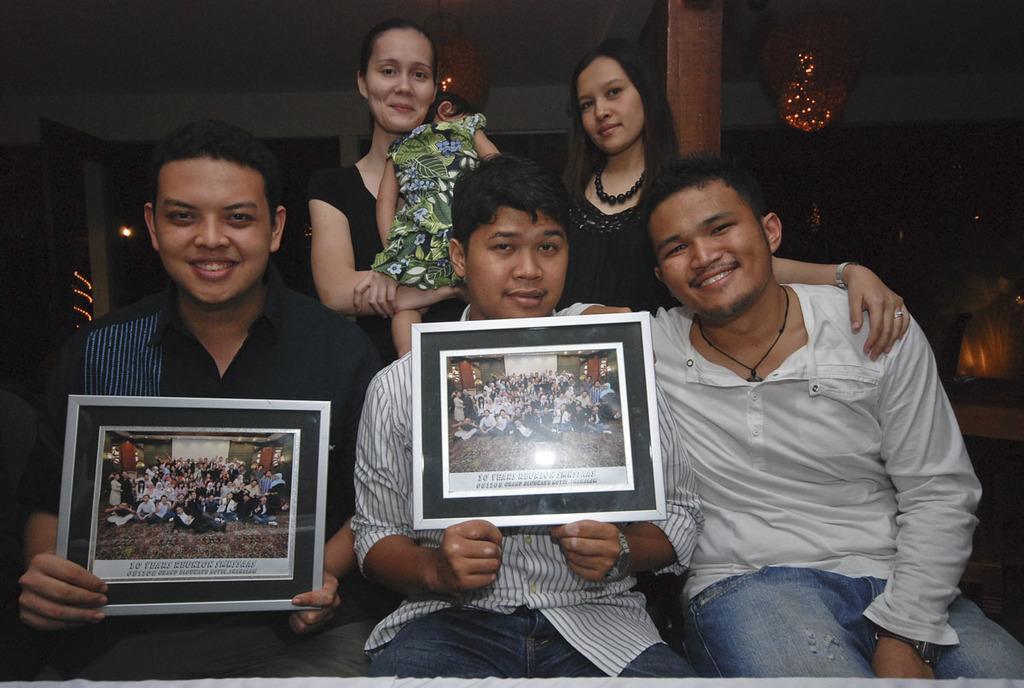How would you summarize this image in a sentence or two? In this picture I can observe six members. There are men, women and a child in this picture. Two of them are holding photo frame in their hands. The background is dark. 